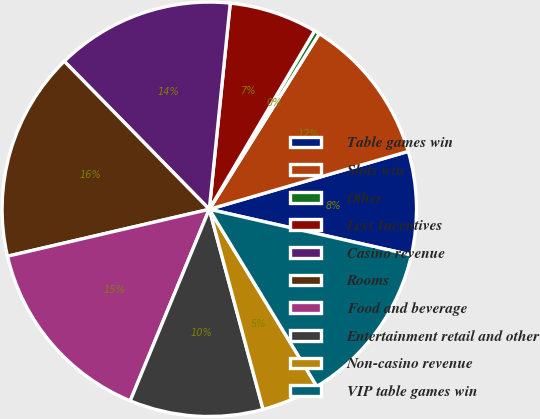<chart> <loc_0><loc_0><loc_500><loc_500><pie_chart><fcel>Table games win<fcel>Slots win<fcel>Other<fcel>Less Incentives<fcel>Casino revenue<fcel>Rooms<fcel>Food and beverage<fcel>Entertainment retail and other<fcel>Non-casino revenue<fcel>VIP table games win<nl><fcel>8.05%<fcel>11.59%<fcel>0.42%<fcel>6.87%<fcel>13.95%<fcel>16.3%<fcel>15.13%<fcel>10.41%<fcel>4.51%<fcel>12.77%<nl></chart> 